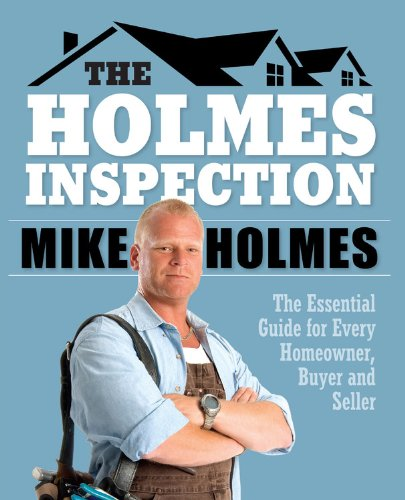Can you describe the type of advice the author is likely to offer in this book? Mike Holmes provides specialized advice on identifying and addressing potential issues in homes which might include structural problems, plumbing issues, and electrical safety. The book likely discusses pragmatic approaches to inspecting a home properly and effectively negotiating repairs or improvements with sellers. 